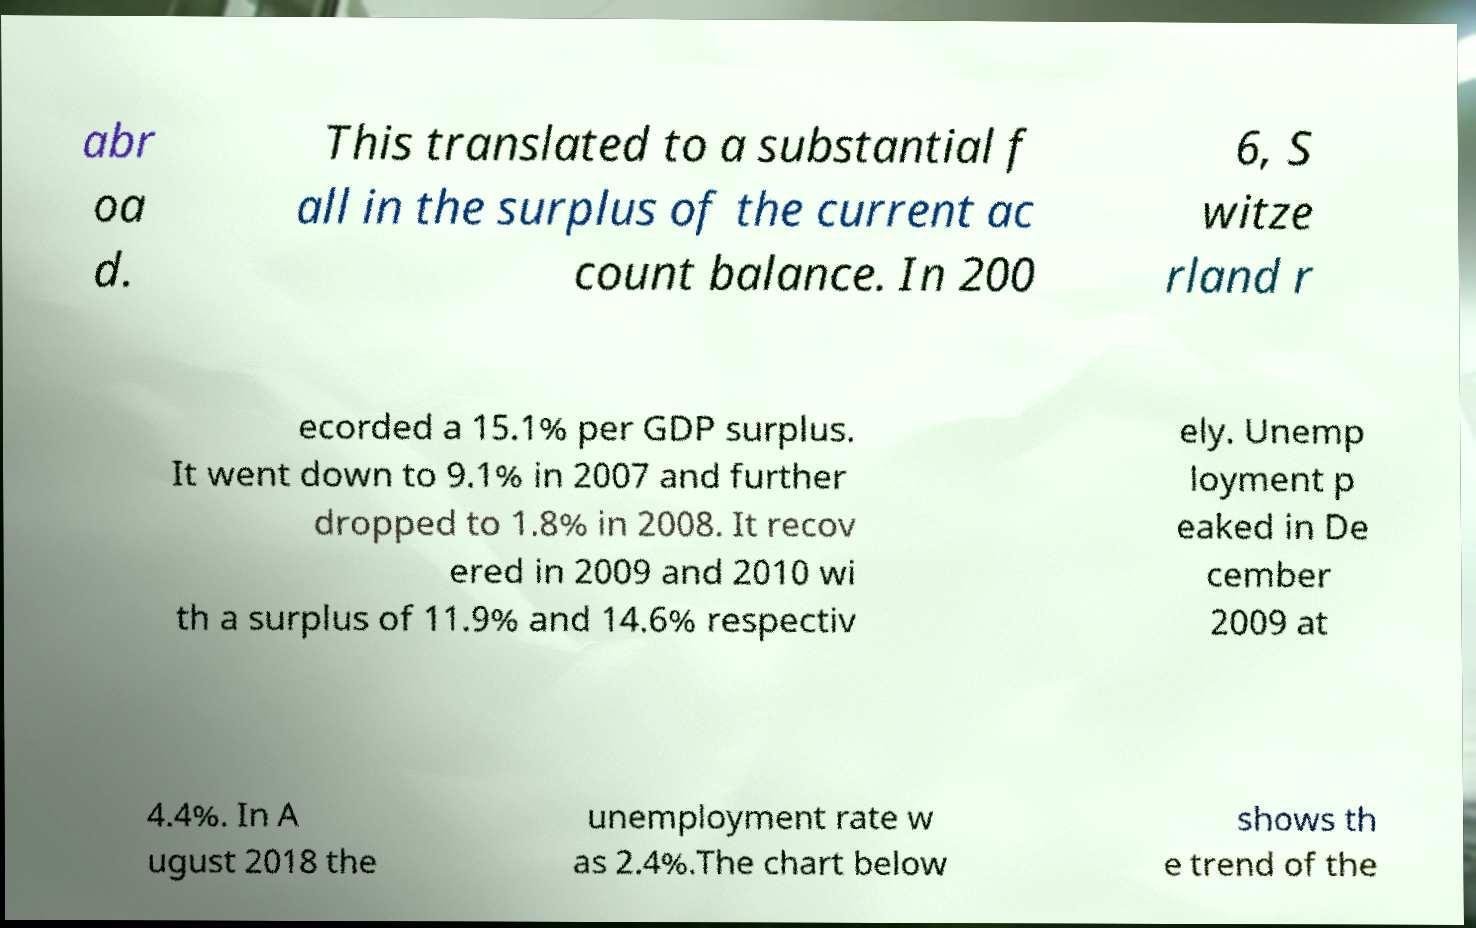I need the written content from this picture converted into text. Can you do that? abr oa d. This translated to a substantial f all in the surplus of the current ac count balance. In 200 6, S witze rland r ecorded a 15.1% per GDP surplus. It went down to 9.1% in 2007 and further dropped to 1.8% in 2008. It recov ered in 2009 and 2010 wi th a surplus of 11.9% and 14.6% respectiv ely. Unemp loyment p eaked in De cember 2009 at 4.4%. In A ugust 2018 the unemployment rate w as 2.4%.The chart below shows th e trend of the 